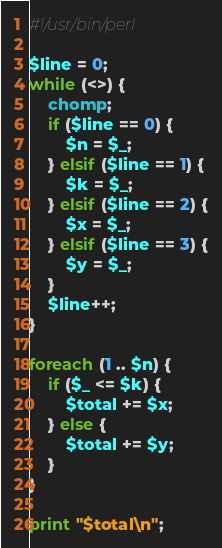<code> <loc_0><loc_0><loc_500><loc_500><_Perl_>#!/usr/bin/perl

$line = 0;
while (<>) {
    chomp;
    if ($line == 0) {
        $n = $_;
    } elsif ($line == 1) {
        $k = $_;
    } elsif ($line == 2) {
        $x = $_;
    } elsif ($line == 3) {
        $y = $_;
    }
    $line++;
}

foreach (1 .. $n) {
    if ($_ <= $k) {
        $total += $x;
    } else {
        $total += $y;
    }
}

print "$total\n";
</code> 